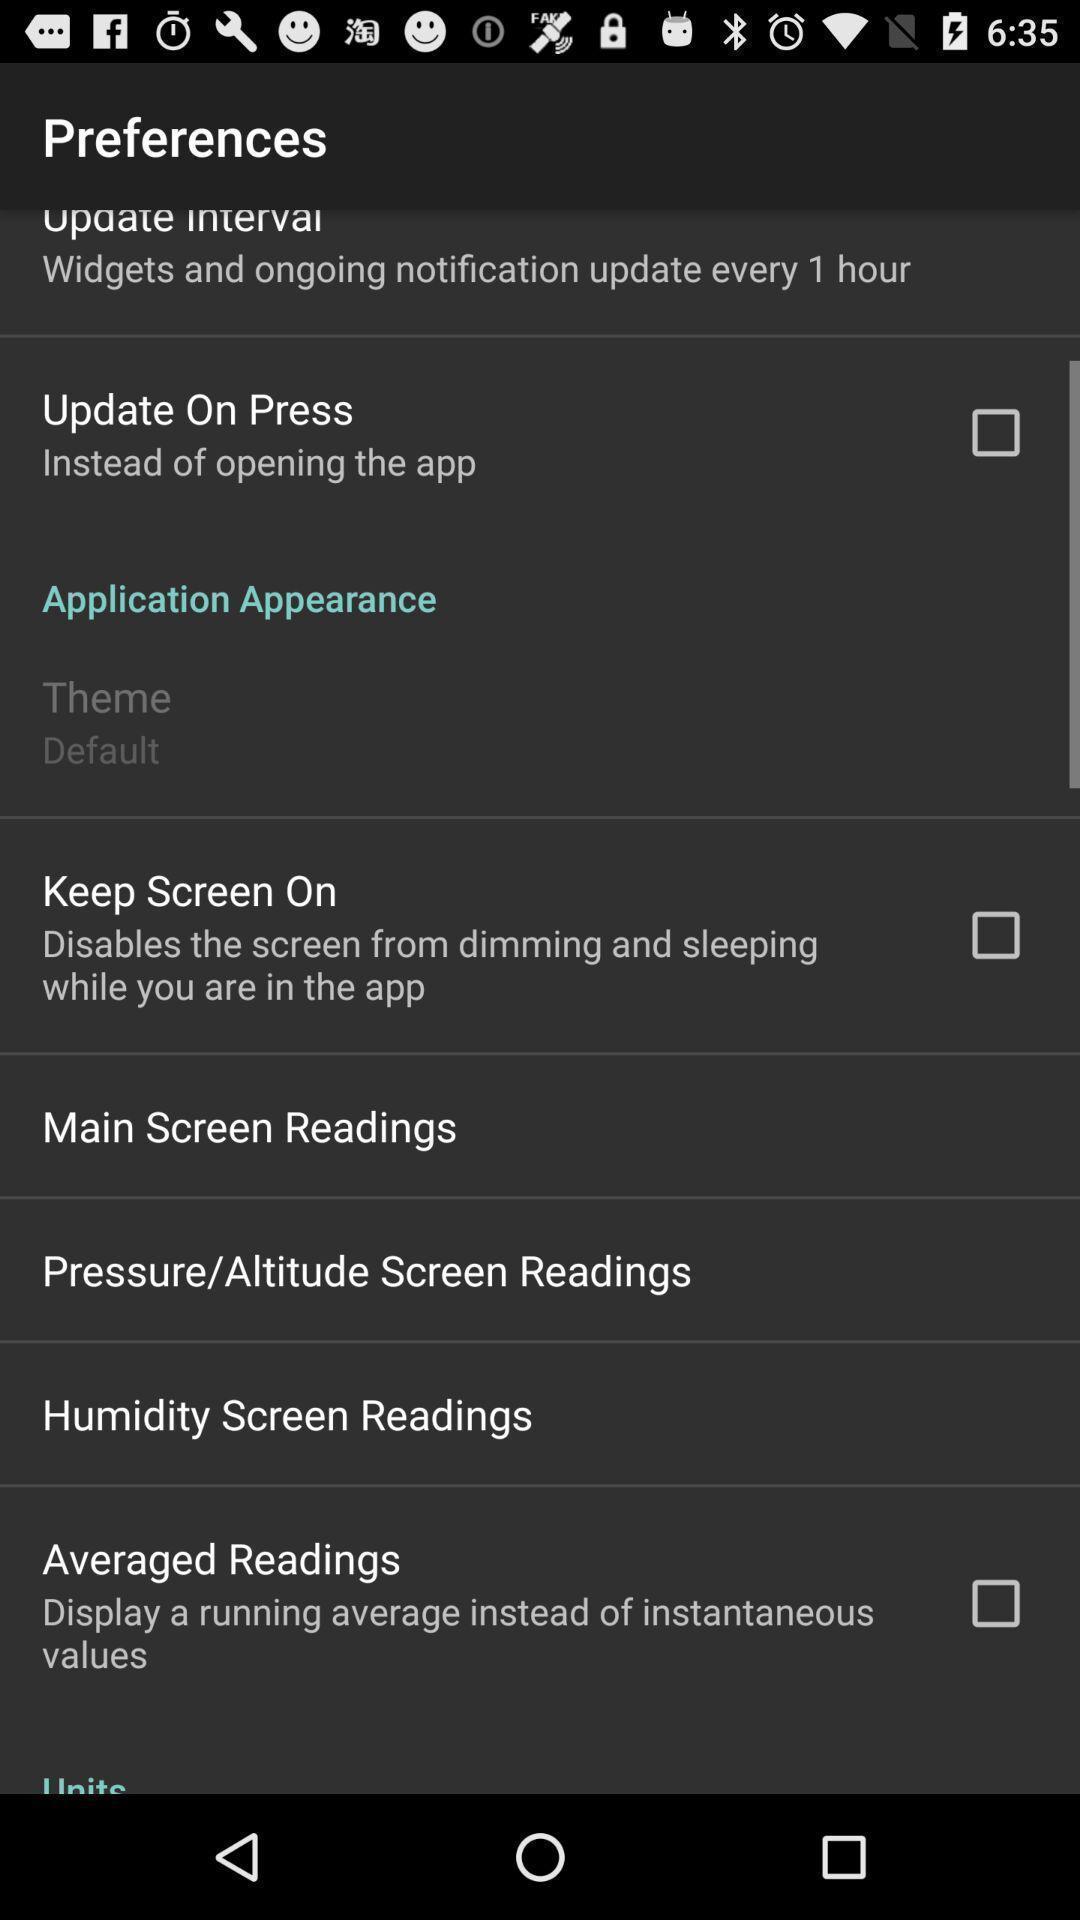Describe the visual elements of this screenshot. Page showing preferences options. 